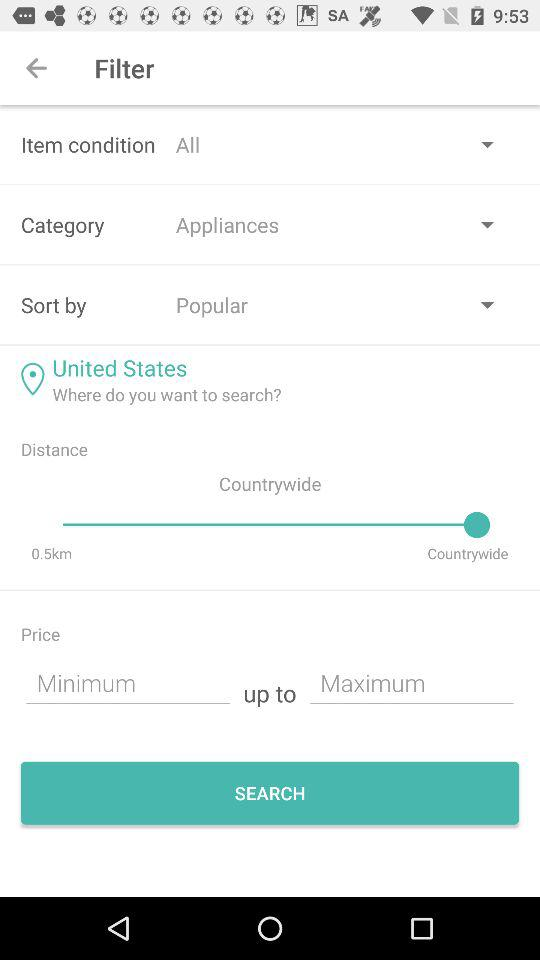What option is selected in the category field? The selected option is "Appliances". 